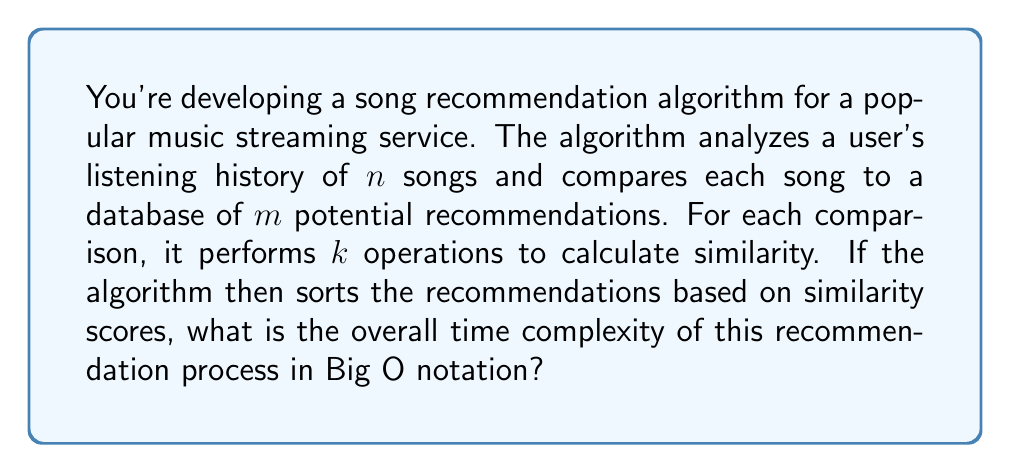Solve this math problem. Let's break down the algorithm and analyze its time complexity step by step:

1. Analyzing user's listening history:
   - The algorithm needs to process $n$ songs from the user's history.

2. Comparing each song to potential recommendations:
   - For each of the $n$ songs, it compares with $m$ potential recommendations.
   - This results in $n \times m$ comparisons.

3. Calculating similarity:
   - For each comparison, $k$ operations are performed.
   - This adds a factor of $k$ to the comparisons.
   - The total operations for comparisons become $n \times m \times k$.

4. Sorting recommendations:
   - After calculating similarities, the algorithm sorts the $m$ recommendations.
   - Using an efficient sorting algorithm like Merge Sort or Quick Sort, this step has a time complexity of $O(m \log m)$.

Now, let's combine these steps:

- The comparison step has a time complexity of $O(nmk)$.
- The sorting step has a time complexity of $O(m \log m)$.

The overall time complexity is the sum of these two steps:

$$O(nmk + m \log m)$$

In Big O notation, we focus on the dominant term as the input size grows. Since $n$, $m$, and $k$ are independent variables, we cannot simplify this further without additional information about their relative sizes.

However, in most practical scenarios, the number of songs in a user's history ($n$) and the number of operations for similarity calculation ($k$) are likely to be much smaller than the number of potential recommendations ($m$). In such cases, the $nmk$ term would dominate, and we could simplify the complexity to $O(nmk)$.
Answer: $O(nmk + m \log m)$ 